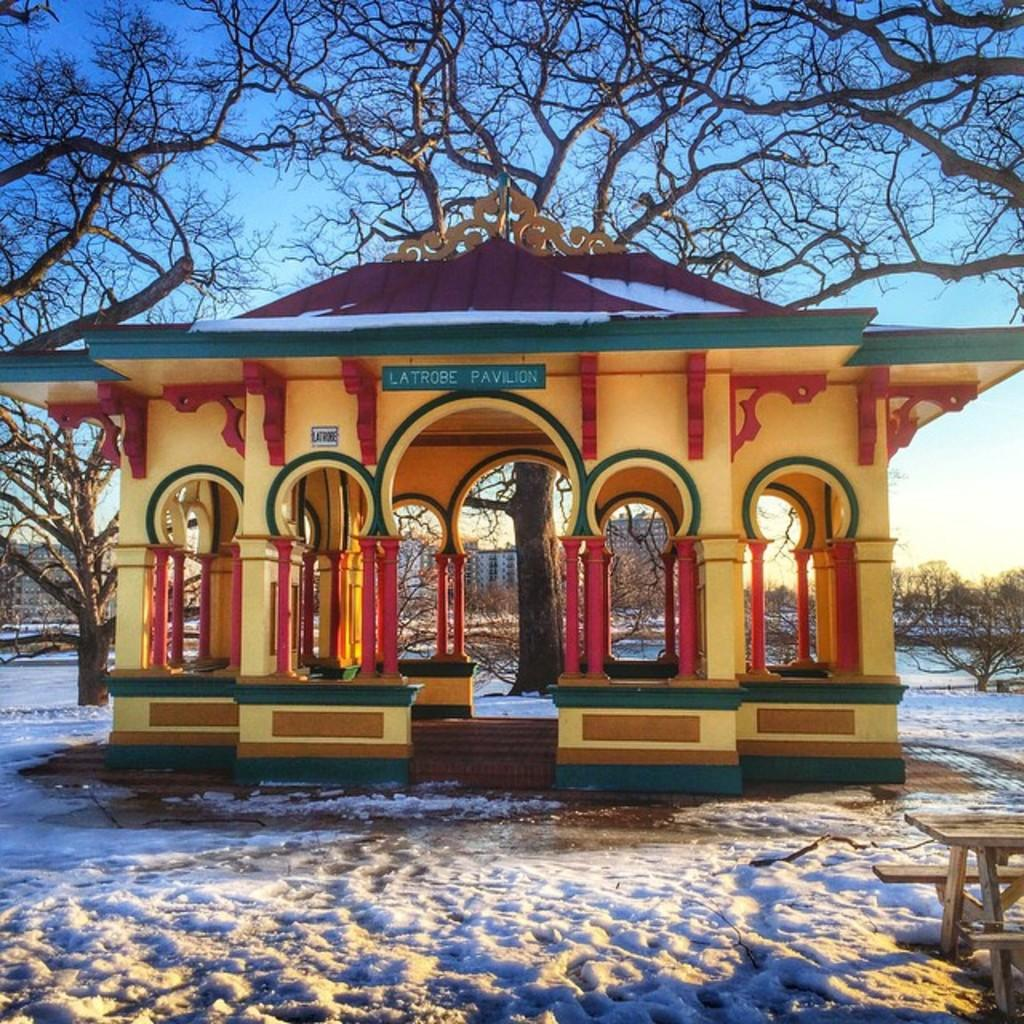What type of structure is visible in the image? There is a house in the image. What can be seen behind the house? There are trees behind the house. What piece of outdoor furniture is in front of the house? There is a wooden bench in front of the house. What is covering the surface in front of the house? The surface in front of the house is covered in snow. What type of curtain is hanging in the window of the house in the image? There is no curtain visible in the image; only the house, trees, wooden bench, and snow-covered surface are present. 